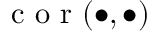<formula> <loc_0><loc_0><loc_500><loc_500>c o r ( \bullet , \bullet )</formula> 